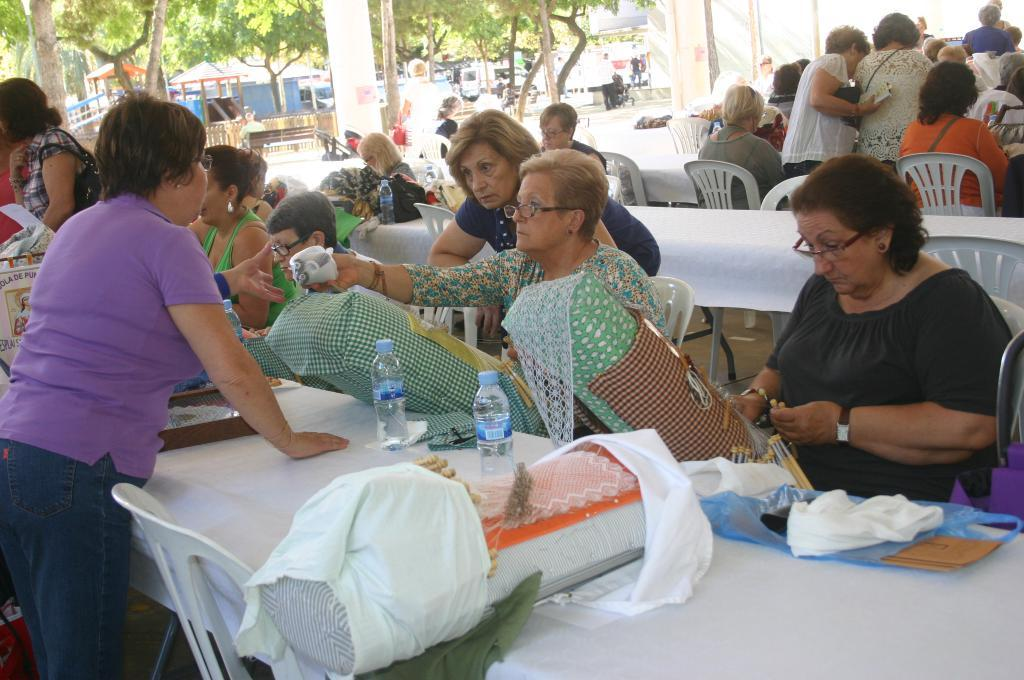What is happening in the image? There is a group of people in the image. What are the people doing in the image? The people are sitting on chairs. What can be seen in the middle of the image? There are trees in the middle of the image. Where is the kettle located in the image? There is no kettle present in the image. What type of celery can be seen growing near the trees in the image? There is no celery present in the image; only trees are mentioned. 